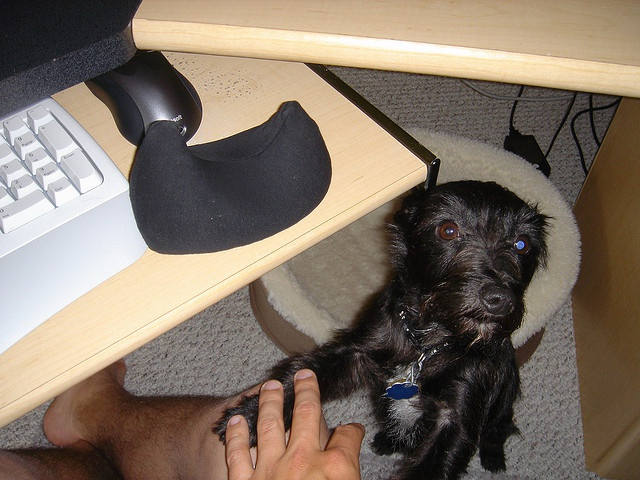Describe the objects in this image and their specific colors. I can see dog in black and gray tones, people in black, maroon, gray, and brown tones, keyboard in black, lightgray, darkgray, and gray tones, and mouse in black, gray, and darkgray tones in this image. 